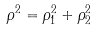Convert formula to latex. <formula><loc_0><loc_0><loc_500><loc_500>\rho ^ { 2 } = \rho _ { 1 } ^ { 2 } + \rho _ { 2 } ^ { 2 }</formula> 